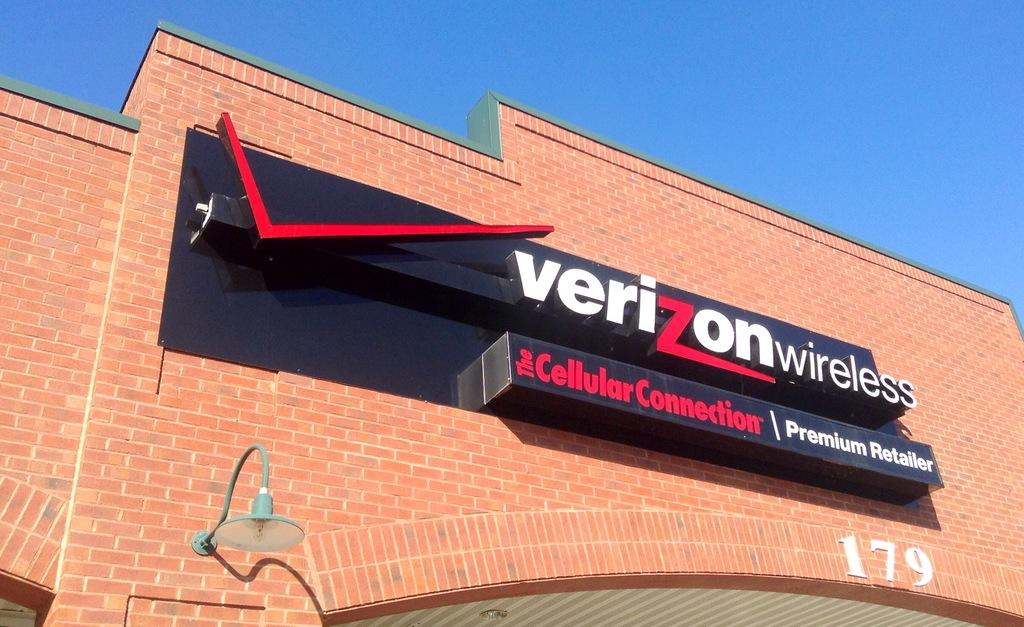<image>
Summarize the visual content of the image. The signage that reads Verizon Wireless on it. 